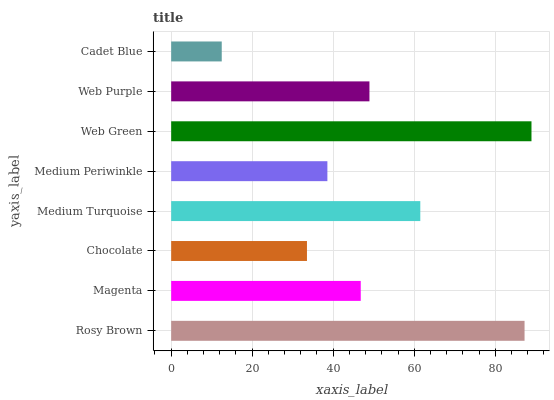Is Cadet Blue the minimum?
Answer yes or no. Yes. Is Web Green the maximum?
Answer yes or no. Yes. Is Magenta the minimum?
Answer yes or no. No. Is Magenta the maximum?
Answer yes or no. No. Is Rosy Brown greater than Magenta?
Answer yes or no. Yes. Is Magenta less than Rosy Brown?
Answer yes or no. Yes. Is Magenta greater than Rosy Brown?
Answer yes or no. No. Is Rosy Brown less than Magenta?
Answer yes or no. No. Is Web Purple the high median?
Answer yes or no. Yes. Is Magenta the low median?
Answer yes or no. Yes. Is Medium Periwinkle the high median?
Answer yes or no. No. Is Medium Turquoise the low median?
Answer yes or no. No. 